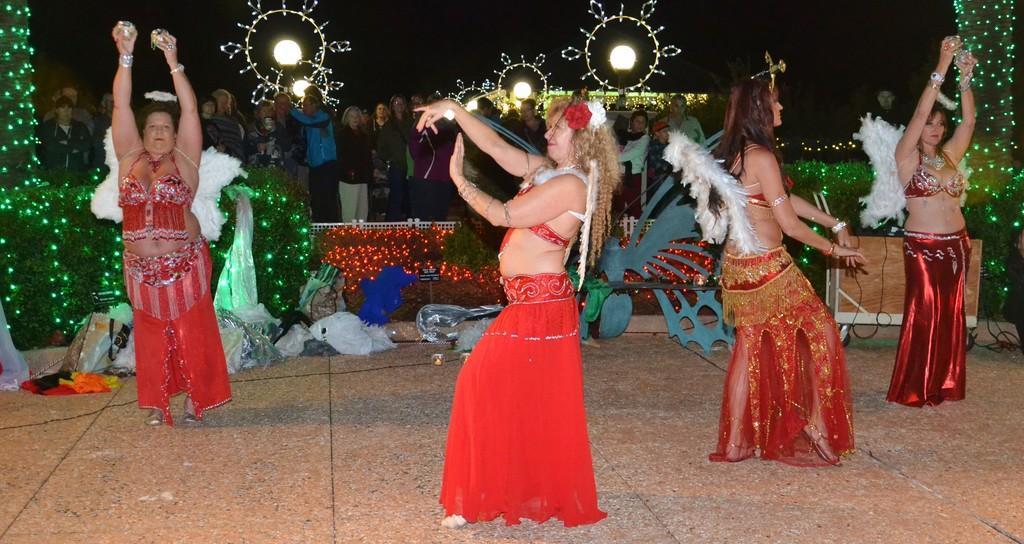Describe this image in one or two sentences. In the foreground I can see four persons are performing a dance on the floor and decorating items. In the background I can see metal rods, fence, crowd, lights, wires, table and the sky. This image is taken may be during night. 